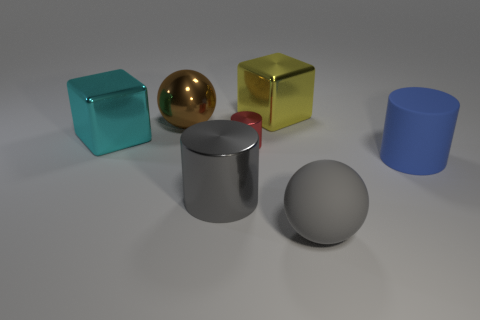Subtract all large cylinders. How many cylinders are left? 1 Add 2 tiny cylinders. How many objects exist? 9 Subtract all yellow blocks. How many blocks are left? 1 Subtract 1 balls. How many balls are left? 1 Subtract 1 blue cylinders. How many objects are left? 6 Subtract all cylinders. How many objects are left? 4 Subtract all brown cylinders. Subtract all yellow blocks. How many cylinders are left? 3 Subtract all big cylinders. Subtract all large cyan metallic objects. How many objects are left? 4 Add 7 rubber balls. How many rubber balls are left? 8 Add 7 small cyan cylinders. How many small cyan cylinders exist? 7 